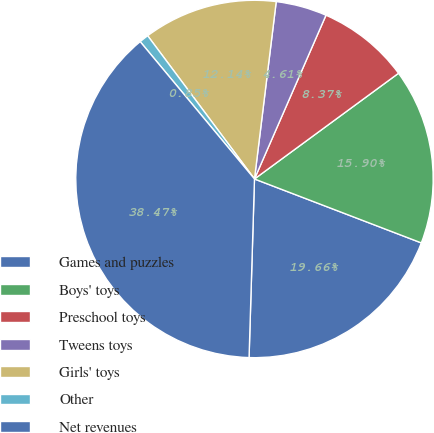Convert chart to OTSL. <chart><loc_0><loc_0><loc_500><loc_500><pie_chart><fcel>Games and puzzles<fcel>Boys' toys<fcel>Preschool toys<fcel>Tweens toys<fcel>Girls' toys<fcel>Other<fcel>Net revenues<nl><fcel>19.66%<fcel>15.9%<fcel>8.37%<fcel>4.61%<fcel>12.14%<fcel>0.85%<fcel>38.47%<nl></chart> 